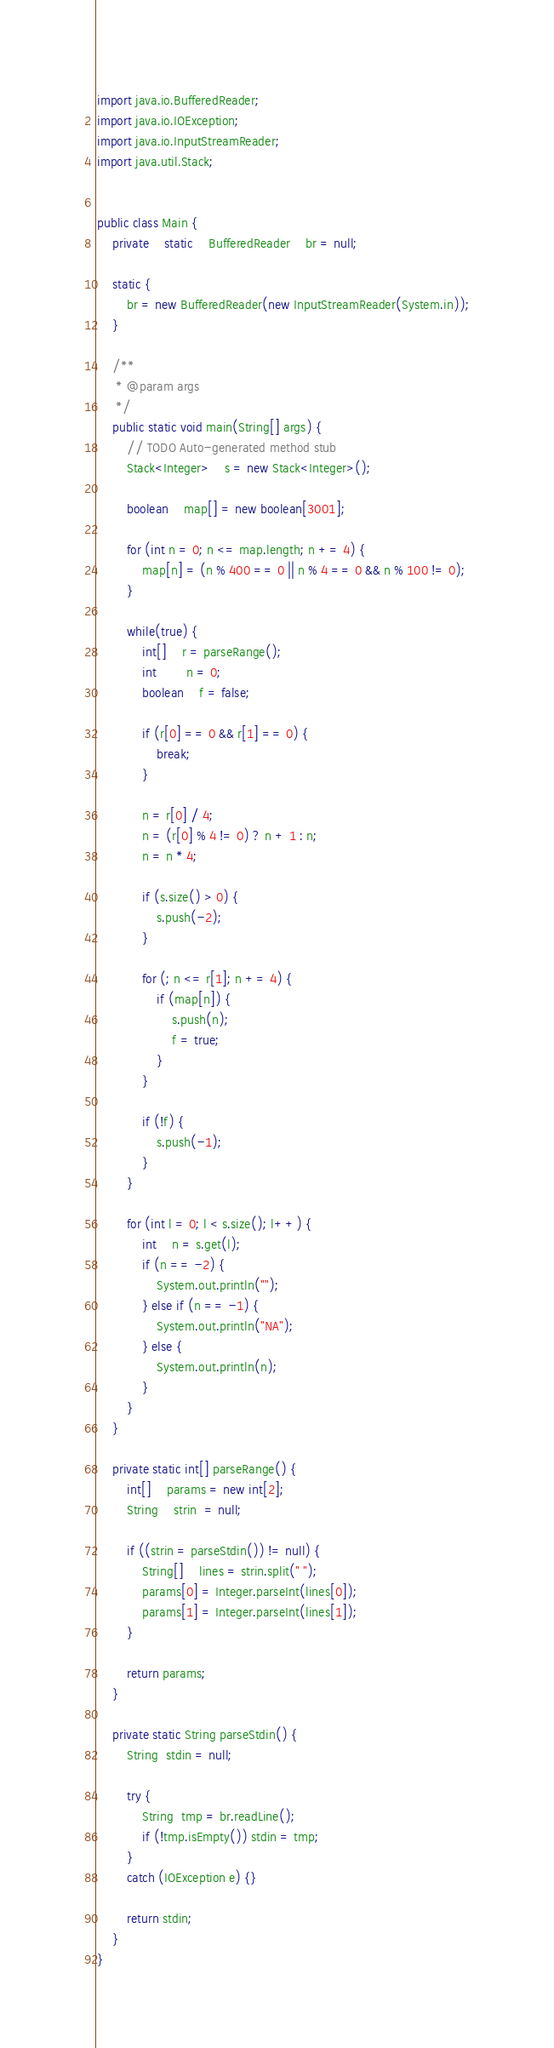<code> <loc_0><loc_0><loc_500><loc_500><_Java_>import java.io.BufferedReader;
import java.io.IOException;
import java.io.InputStreamReader;
import java.util.Stack;


public class Main {
	private	static	BufferedReader	br = null;

	static {
		br = new BufferedReader(new InputStreamReader(System.in));
	}
 
    /**
     * @param args
     */
	public static void main(String[] args) {
		// TODO Auto-generated method stub
		Stack<Integer>	s = new Stack<Integer>();

		boolean	map[] = new boolean[3001];

		for (int n = 0; n <= map.length; n += 4) {
			map[n] = (n % 400 == 0 || n % 4 == 0 && n % 100 != 0);
		}

		while(true) {
			int[]	r = parseRange();
			int		n = 0;
			boolean	f = false;

			if (r[0] == 0 && r[1] == 0) {
				break;
			}

			n = r[0] / 4;
			n = (r[0] % 4 != 0) ? n + 1 : n;
			n = n * 4;

			if (s.size() > 0) {
				s.push(-2);
			}

			for (; n <= r[1]; n += 4) {
				if (map[n]) {
					s.push(n);
					f = true;
				}
			}

			if (!f) {
				s.push(-1);
			}
		}

		for (int l = 0; l < s.size(); l++) {
			int	n = s.get(l);
			if (n == -2) {
				System.out.println("");
			} else if (n == -1) {
				System.out.println("NA");
			} else {
				System.out.println(n);
			}
		}
	}

	private static int[] parseRange() {
		int[]	params = new int[2];
		String	strin  = null;

		if ((strin = parseStdin()) != null) {
			String[]	lines = strin.split(" ");
			params[0] = Integer.parseInt(lines[0]);
			params[1] = Integer.parseInt(lines[1]);
		}
 
		return params;
	}

	private static String parseStdin() {
        String  stdin = null;
        
        try {
        	String  tmp = br.readLine();
        	if (!tmp.isEmpty()) stdin = tmp;
        }
        catch (IOException e) {}
 
        return stdin;
	}
}</code> 